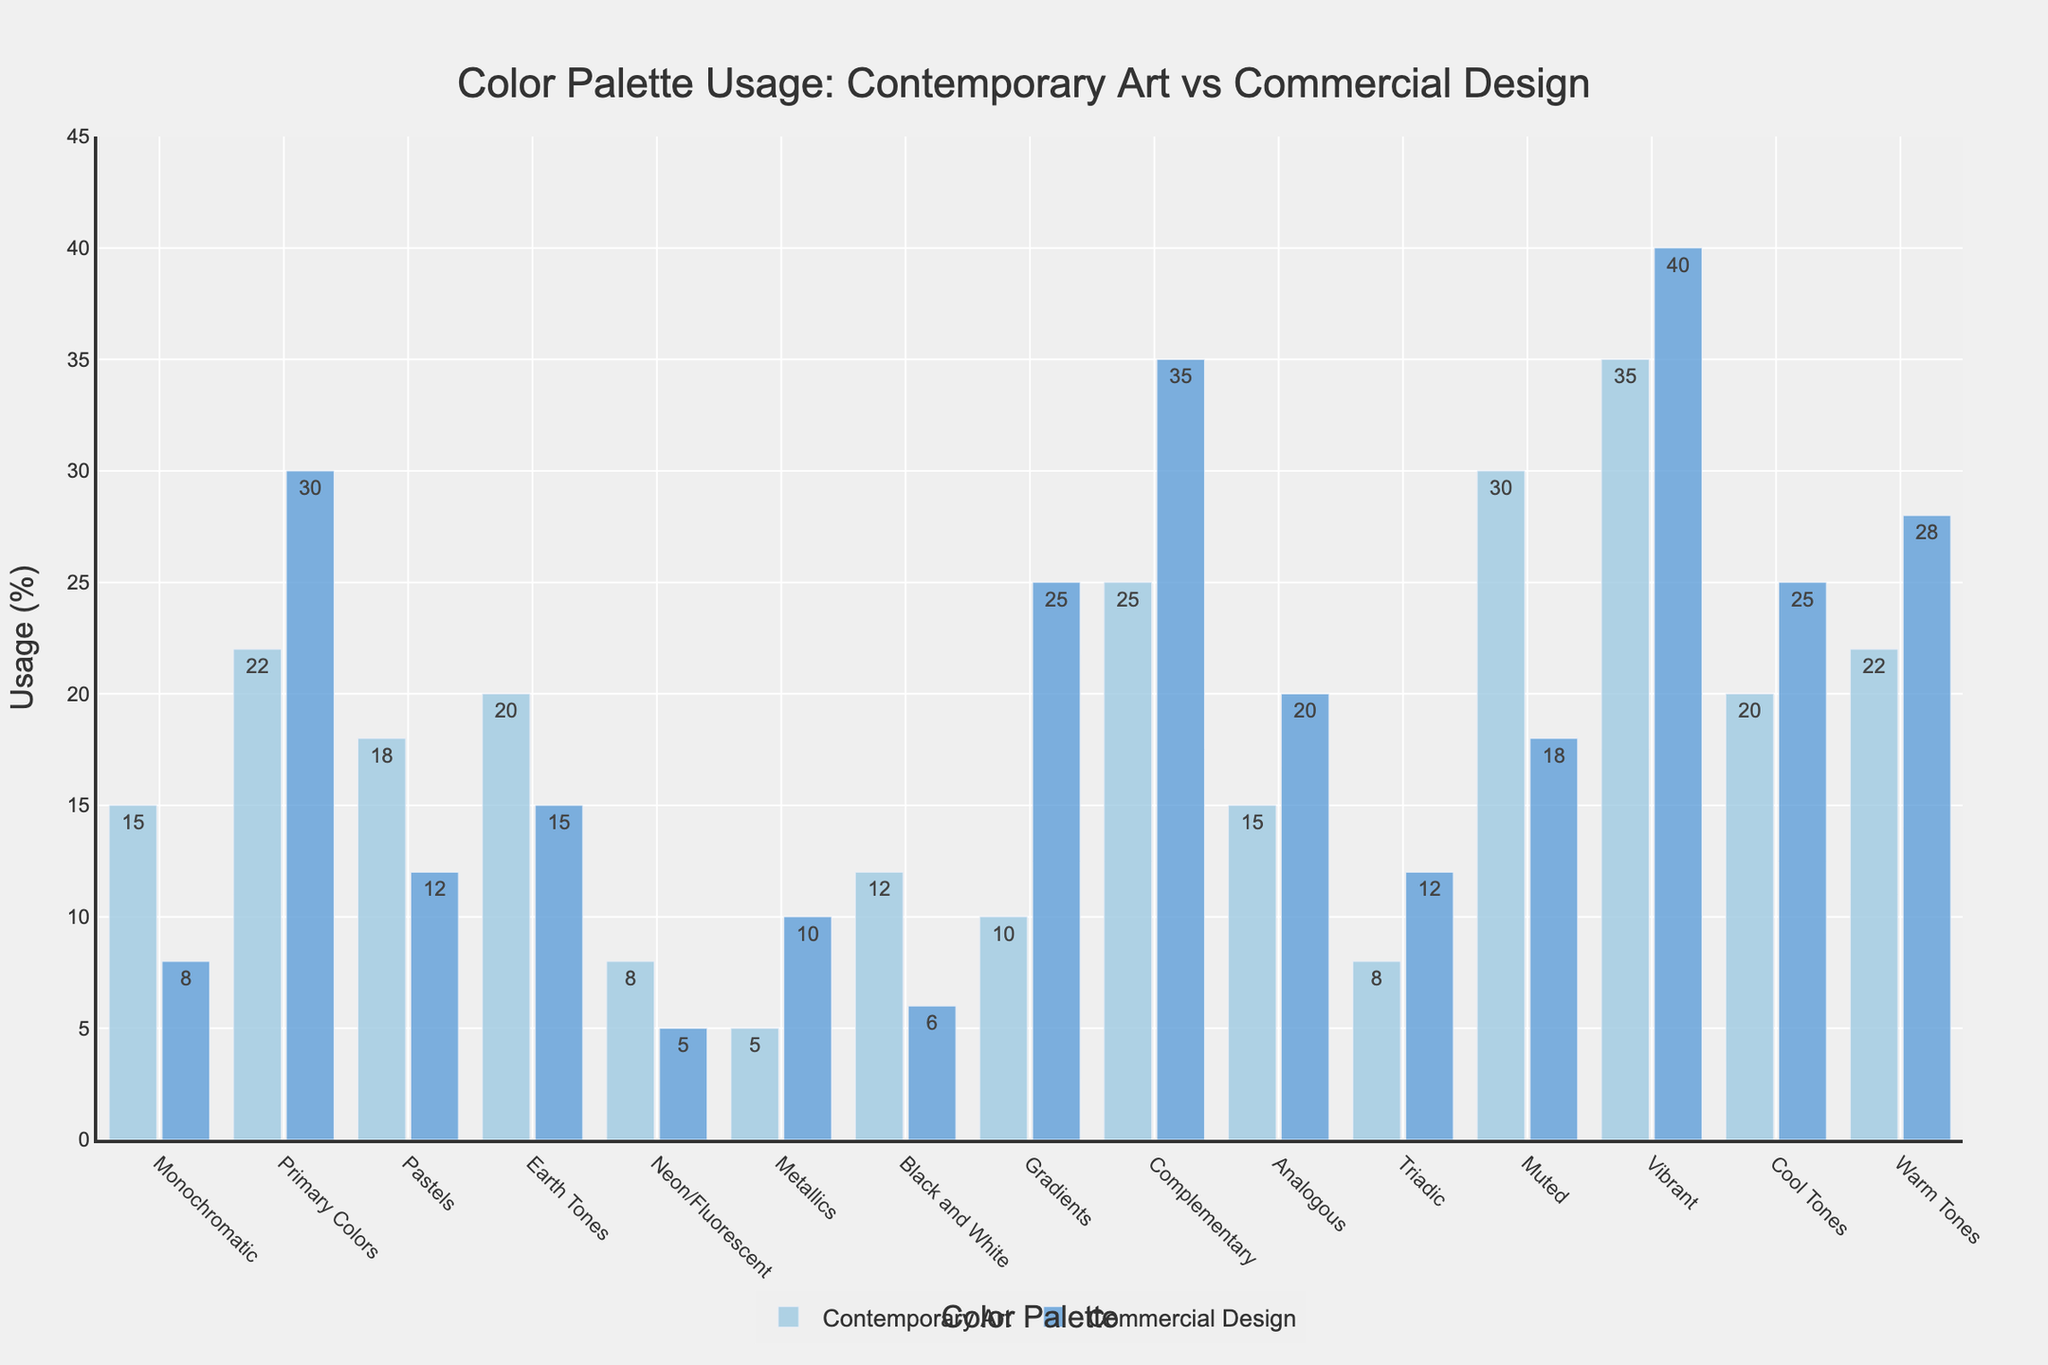What is the difference in the usage percentage of Vibrant colors between Contemporary Art and Commercial Design? To find the difference, subtract the usage percentage of Vibrant colors in Contemporary Art from Commercial Design: 40% - 35% = 5%.
Answer: 5% In which category do Contemporary Art and Commercial Design have the largest discrepancy in color palette usage? Look for the category with the largest difference between the two percentages. The largest discrepancy is in the Gradients category, with a difference of 15% (25% in Commercial Design versus 10% in Contemporary Art).
Answer: Gradients Which palette has a higher usage in Contemporary Art compared to Commercial Design? Compare the percentages in Contemporary Art and Commercial Design for each color palette. The palettes with higher usage in Contemporary Art include Monochromatic, Pastels, Earth Tones, Black and White, Muted, and Vibrant.
Answer: Monochromatic, Pastels, Earth Tones, Black and White, Muted, Vibrant What is the average usage percentage of Primary Colors and Complementary Colors in Commercial Design? To find the average, sum up the usage percentages of Primary Colors (30%) and Complementary Colors (35%), then divide by 2: (30% + 35%) / 2 = 32.5%.
Answer: 32.5% Is the usage of Monochromatic colors in Contemporary Art greater than, less than, or equal to its usage in Commercial Design? Compare the two percentages: 15% in Contemporary Art and 8% in Commercial Design. 15% is greater than 8%.
Answer: Greater than Between Metallics and Neon/Fluorescent, which has a greater usage in Commercial Design? Look at the Commercial Design usage percentages for Metallics (10%) and Neon/Fluorescent (5%). Metallics have a greater usage.
Answer: Metallics What is the total percentage usage of Cool Tones and Warm Tones in Contemporary Art? Sum up the usage percentages of Cool Tones (20%) and Warm Tones (22%) in Contemporary Art: 20% + 22% = 42%.
Answer: 42% How does the usage of Analogous colors compare between Contemporary Art and Commercial Design? Compare the percentages of Analogous colors in Contemporary Art (15%) and Commercial Design (20%). The usage in Commercial Design is greater by 5%.
Answer: Commercial Design is greater by 5% Which color palettes have identical usage percentages in both Contemporary Art and Commercial Design? Check each palette for identical percentages. The palette with identical percentages is Monochromatic, with both having 15%.
Answer: Monochromatic 